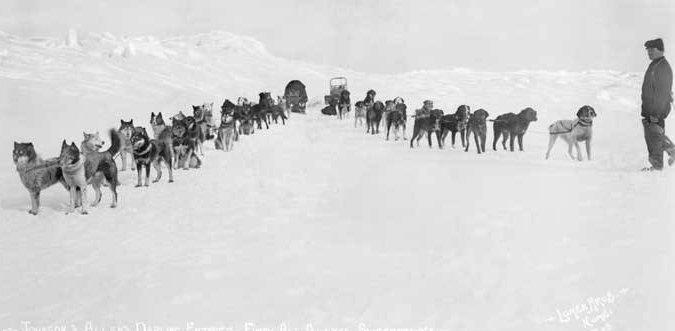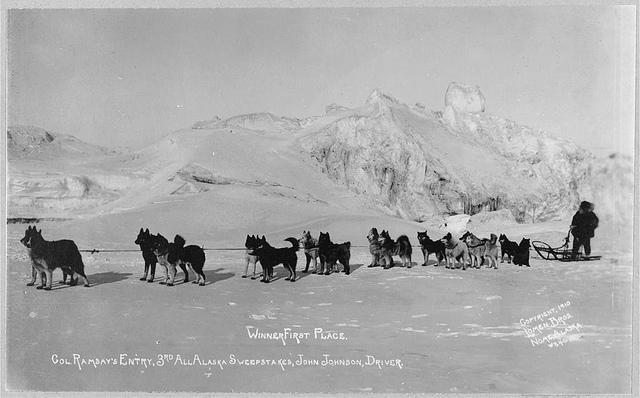The first image is the image on the left, the second image is the image on the right. Assess this claim about the two images: "The left image shows a fur-hooded sled driver standing behind an old-fashioned long wooden sled, and the right image shows a dog sled near buildings.". Correct or not? Answer yes or no. No. The first image is the image on the left, the second image is the image on the right. Given the left and right images, does the statement "None of the lead dogs appear to be mostly white fur." hold true? Answer yes or no. Yes. 